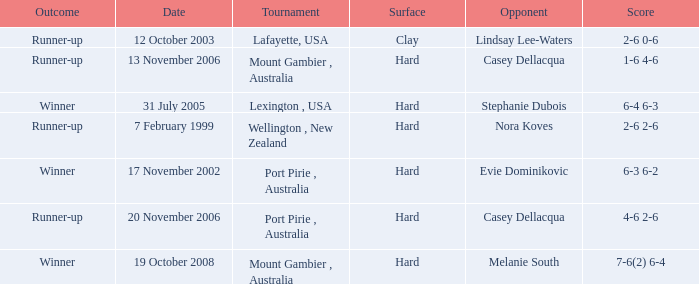Which is the Outcome on 13 november 2006? Runner-up. 